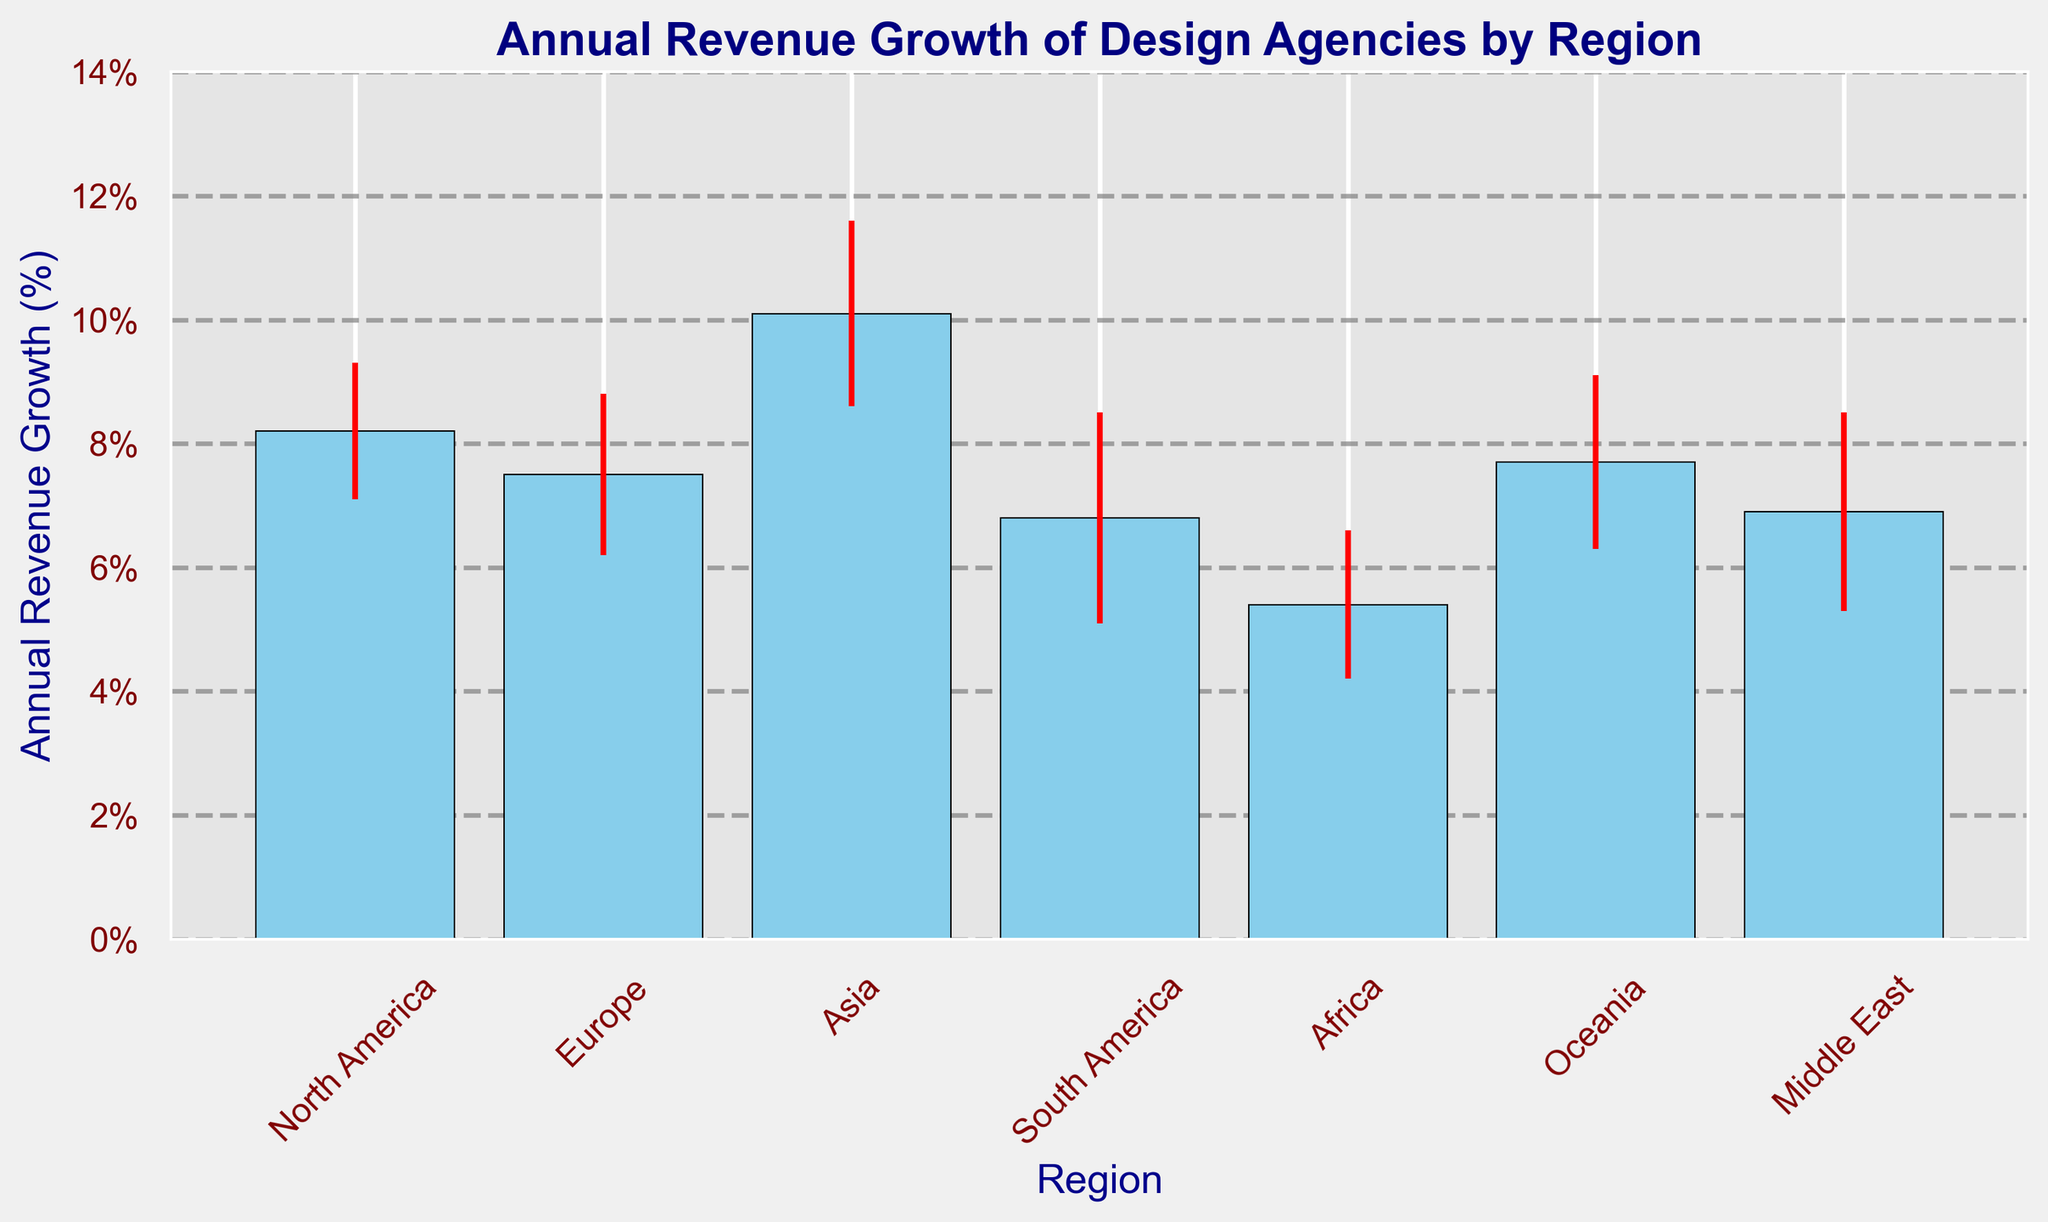What's the annual revenue growth for Asia? The figure shows a bar for each region with a label indicating annual revenue growth. For Asia, the bar indicates 10.1% annual revenue growth.
Answer: 10.1% Which region has the lowest revenue growth? By observing the height of the bars, Africa has the shortest bar indicating the lowest revenue growth at 5.4%.
Answer: Africa What's the difference in revenue growth between Europe and South America? Europe's annual revenue growth is 7.5% and South America's is 6.8%. The difference is 7.5% - 6.8% = 0.7%.
Answer: 0.7% Which region has the highest error margin? By comparing the error bars on top of the bars, South America has the largest error margin at 1.7%.
Answer: South America On average, what is the revenue growth across all regions? Sum the annual revenue growth percentages from all regions and divide by the number of regions: (8.2 + 7.5 + 10.1 + 6.8 + 5.4 + 7.7 + 6.9) / 7 = 7.51%.
Answer: 7.51% What is the total error margin for Europe and Oceania combined? The error margins for Europe and Oceania are 1.3% and 1.4% respectively. The total error margin is 1.3% + 1.4% = 2.7%.
Answer: 2.7% Is the revenue growth of the Middle East greater than that of Africa? Comparing the bars, the Middle East has a revenue growth of 6.9% and Africa has 5.4%. So, 6.9% > 5.4%.
Answer: Yes Which region’s revenue growth is closest to the average revenue growth across all regions? The average revenue growth across all regions is approximately 7.51%. North America with 8.2% is the closest to this average.
Answer: North America How many regions have a revenue growth higher than 7%? By examining the bar heights, the regions with more than 7% growth are North America, Europe, Asia, and Oceania. This makes a total of 4 regions.
Answer: 4 What's the combined revenue growth of North America and Europe? Adding North America's revenue growth of 8.2% and Europe's 7.5% gives a combined growth of 8.2% + 7.5% = 15.7%.
Answer: 15.7% 